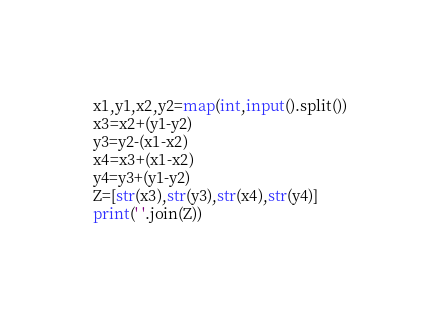Convert code to text. <code><loc_0><loc_0><loc_500><loc_500><_Python_>x1,y1,x2,y2=map(int,input().split())
x3=x2+(y1-y2)
y3=y2-(x1-x2)
x4=x3+(x1-x2)
y4=y3+(y1-y2)
Z=[str(x3),str(y3),str(x4),str(y4)]
print(' '.join(Z))</code> 